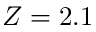Convert formula to latex. <formula><loc_0><loc_0><loc_500><loc_500>Z = 2 . 1</formula> 